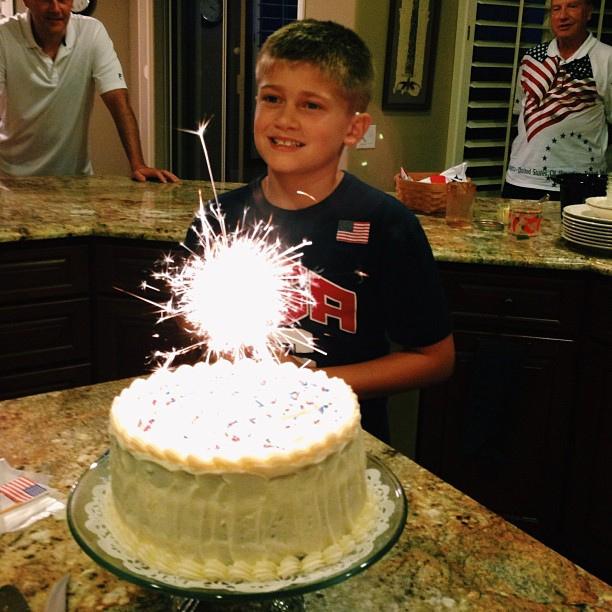Are there candles on the cake?
Give a very brief answer. No. What flag is on the boy's shirt?
Write a very short answer. American. What color is the cake?
Be succinct. White. 